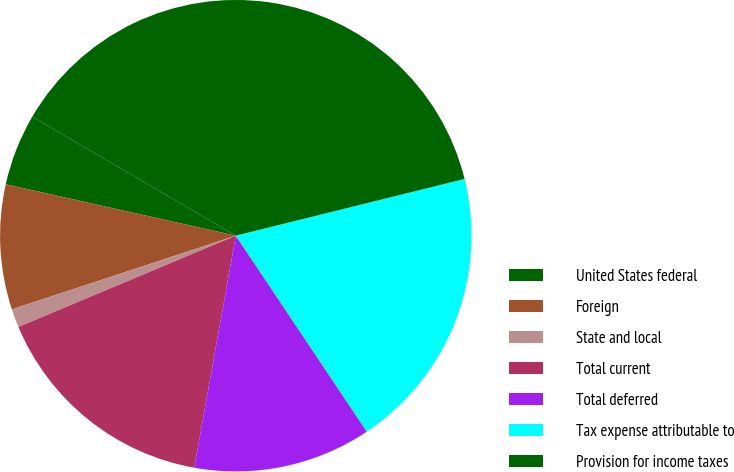<chart> <loc_0><loc_0><loc_500><loc_500><pie_chart><fcel>United States federal<fcel>Foreign<fcel>State and local<fcel>Total current<fcel>Total deferred<fcel>Tax expense attributable to<fcel>Provision for income taxes<nl><fcel>4.92%<fcel>8.56%<fcel>1.27%<fcel>15.85%<fcel>12.2%<fcel>19.49%<fcel>37.71%<nl></chart> 